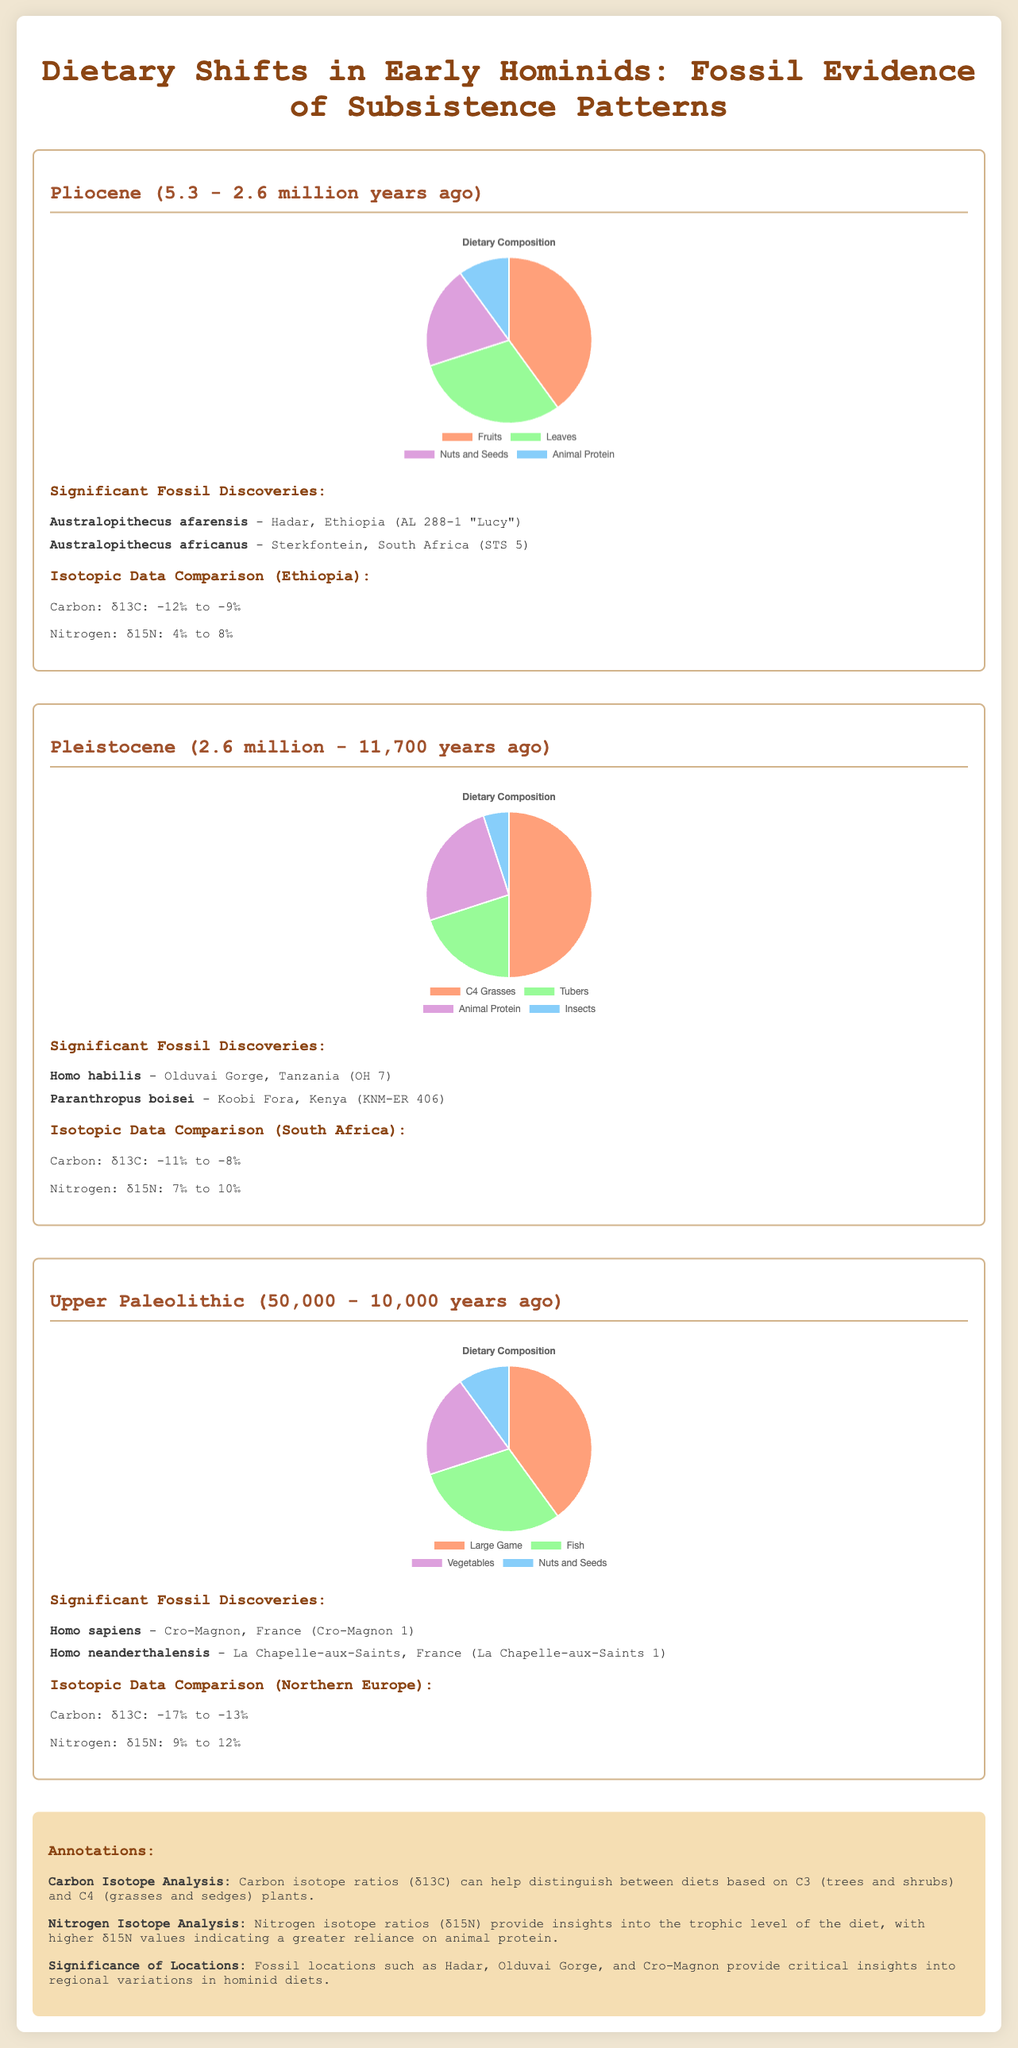what is the time range of the Pliocene period? The time range of the Pliocene period is provided in the document, which states it was from 5.3 to 2.6 million years ago.
Answer: 5.3 - 2.6 million years ago who is a significant fossil discovery from the Upper Paleolithic? The document lists significant fossil discoveries, including Homo sapiens from Cro-Magnon, France.
Answer: Homo sapiens what is the primary dietary composition in the Pleistocene period? The pie chart in the document shows dietary compositions, indicating that C4 Grasses are 50% of the diet during the Pleistocene period.
Answer: 50% what are the carbon isotopic values for the Pliocene period in Ethiopia? The isotopic data comparison states that carbon values in Ethiopia during Pliocene were between -12‰ to -9‰.
Answer: -12‰ to -9‰ which hominid species is associated with Olduvai Gorge? The document includes a list of significant fossil discoveries, stating that Homo habilis is associated with Olduvai Gorge, Tanzania.
Answer: Homo habilis what is the nitrogen isotopic range for the Upper Paleolithic? The nitrogen isotopic data comparison in the document indicates the range is from 9‰ to 12‰ for Northern Europe during the Upper Paleolithic.
Answer: 9‰ to 12‰ which plant types are highlighted in the dietary composition for the Pliocene? The dietary composition in the document mentions Fruits, Leaves, Nuts and Seeds, and Animal Protein as part of Pliocene diets.
Answer: Fruits, Leaves, Nuts and Seeds, and Animal Protein what is the primary protein source in the Pleistocene diet? The pie chart for the Pleistocene indicates that Animal Protein accounts for 25% of the dietary composition.
Answer: 25% what geographic location is highlighted for isotopic comparison in the Pleistocene? The document states that isotopic data comparison for the Pleistocene is provided for South Africa.
Answer: South Africa 